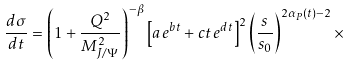Convert formula to latex. <formula><loc_0><loc_0><loc_500><loc_500>\frac { d \sigma } { d t } = \left ( 1 + \frac { Q ^ { 2 } } { M ^ { 2 } _ { J / \Psi } } \right ) ^ { - \beta } \left [ a \, e ^ { b t } + c t \, e ^ { d t } \right ] ^ { 2 } \left ( \frac { s } { s _ { 0 } } \right ) ^ { 2 \alpha _ { P } ( t ) - 2 } \times</formula> 